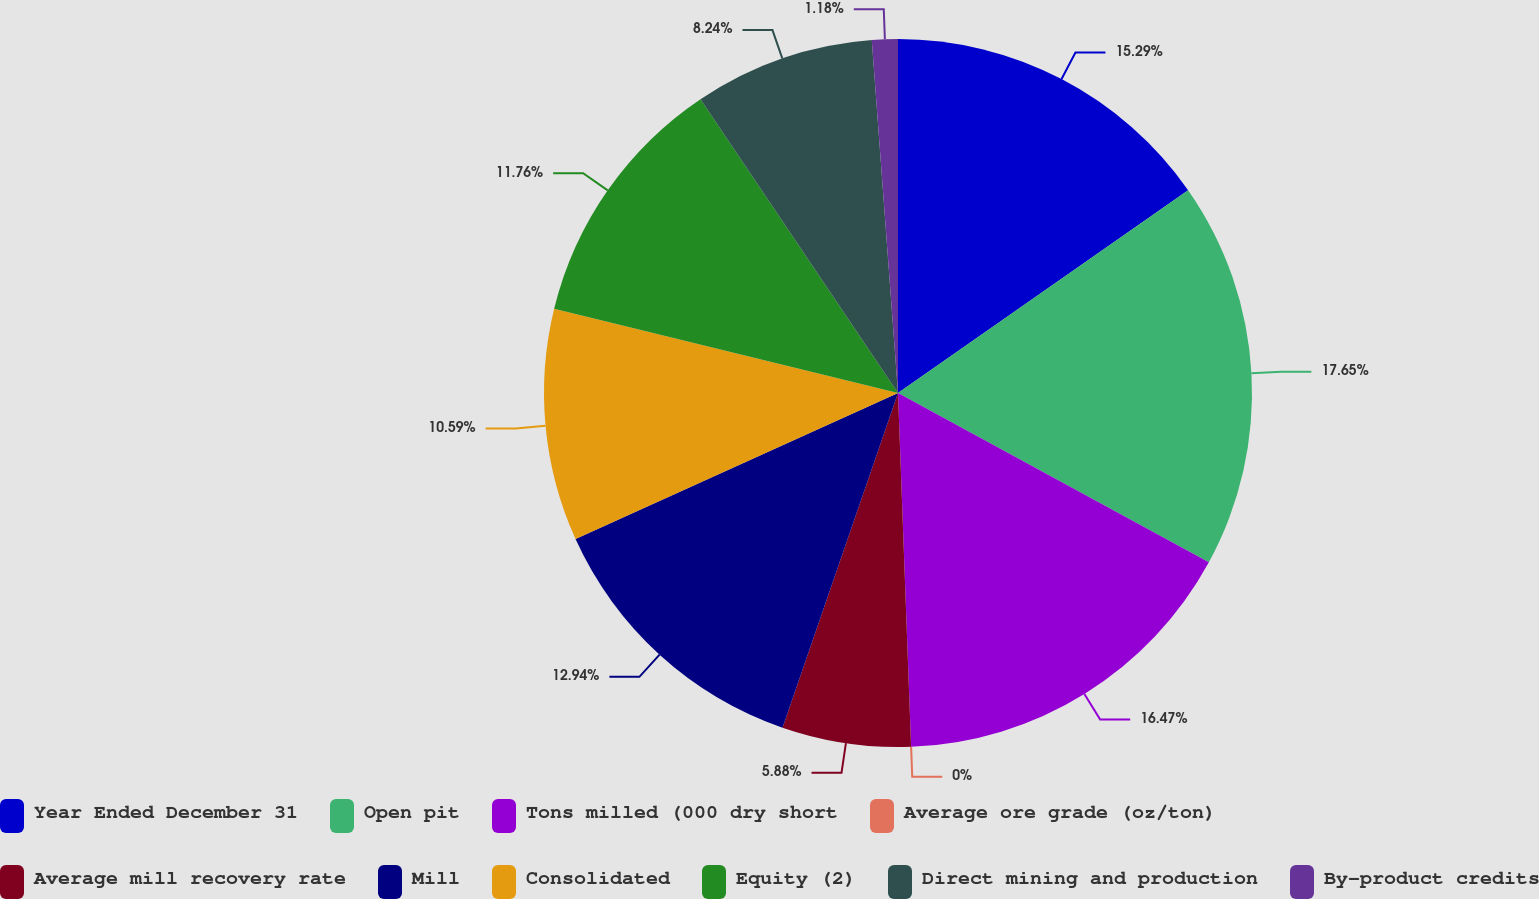<chart> <loc_0><loc_0><loc_500><loc_500><pie_chart><fcel>Year Ended December 31<fcel>Open pit<fcel>Tons milled (000 dry short<fcel>Average ore grade (oz/ton)<fcel>Average mill recovery rate<fcel>Mill<fcel>Consolidated<fcel>Equity (2)<fcel>Direct mining and production<fcel>By-product credits<nl><fcel>15.29%<fcel>17.65%<fcel>16.47%<fcel>0.0%<fcel>5.88%<fcel>12.94%<fcel>10.59%<fcel>11.76%<fcel>8.24%<fcel>1.18%<nl></chart> 